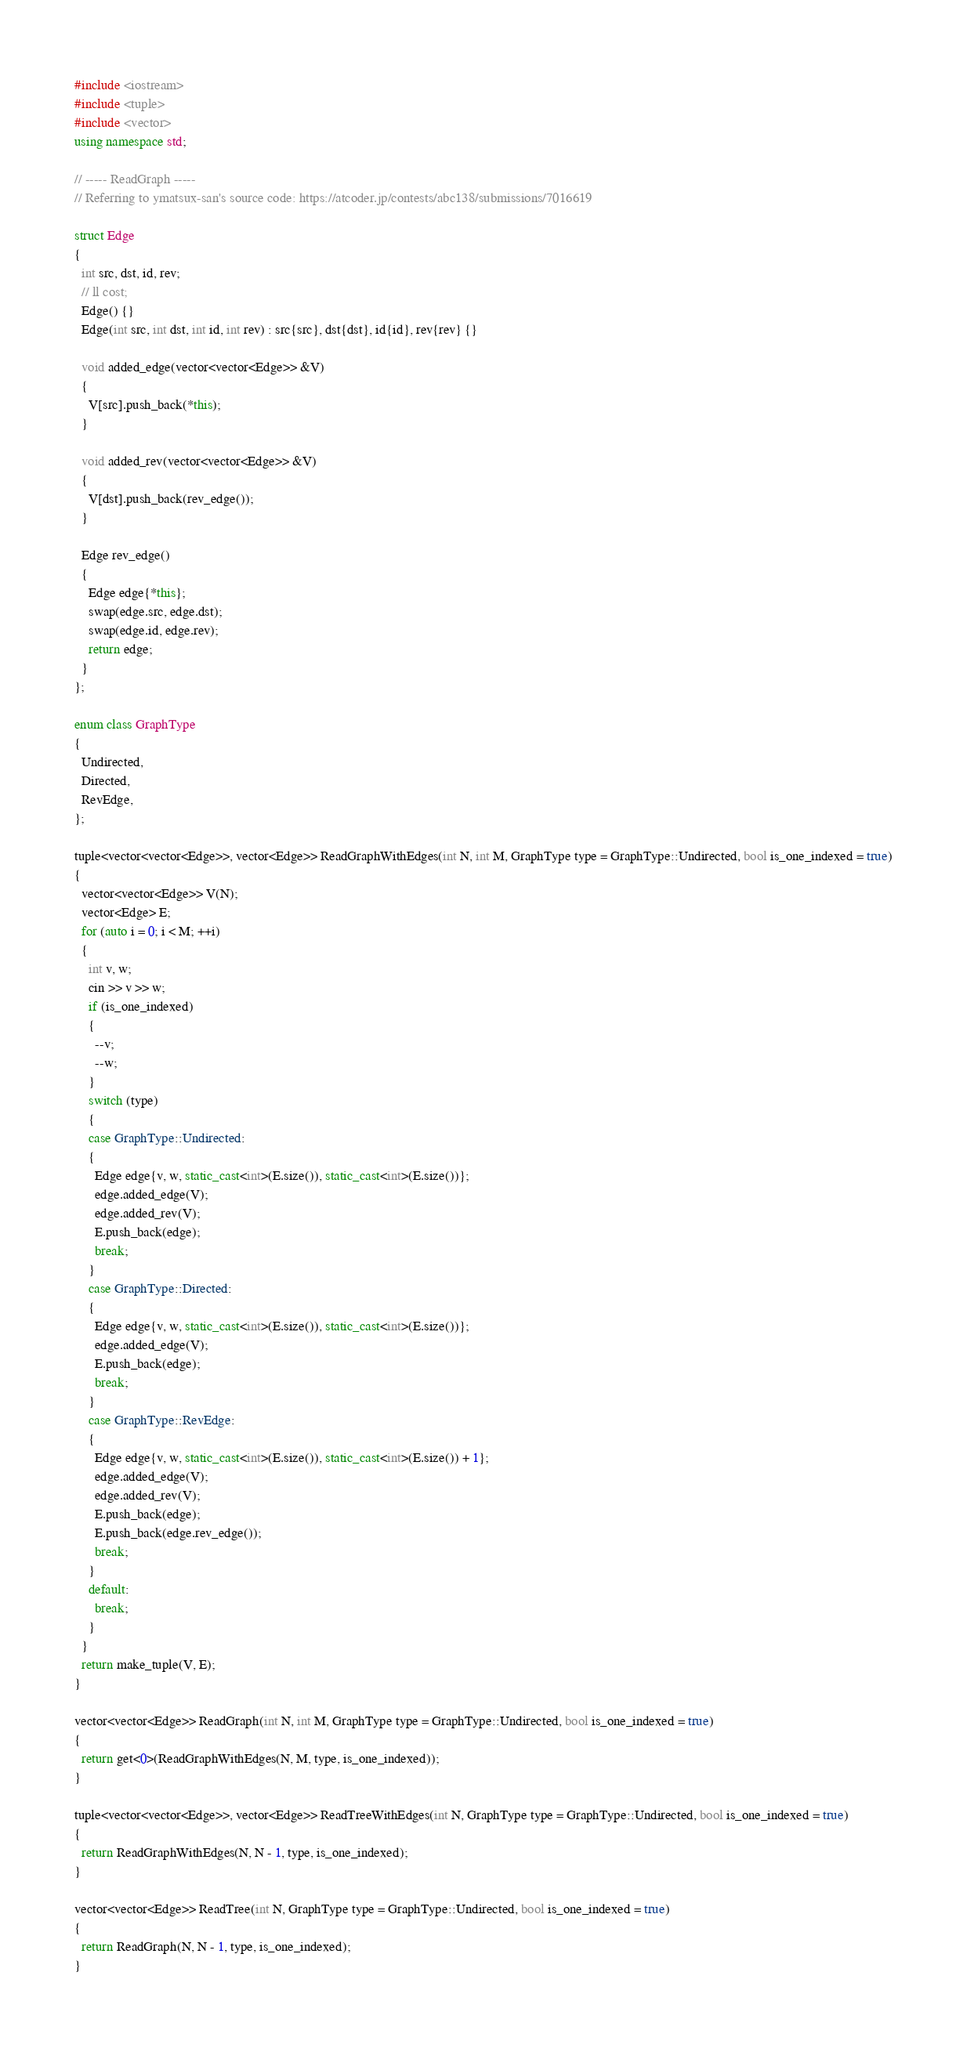<code> <loc_0><loc_0><loc_500><loc_500><_C++_>#include <iostream>
#include <tuple>
#include <vector>
using namespace std;

// ----- ReadGraph -----
// Referring to ymatsux-san's source code: https://atcoder.jp/contests/abc138/submissions/7016619

struct Edge
{
  int src, dst, id, rev;
  // ll cost;
  Edge() {}
  Edge(int src, int dst, int id, int rev) : src{src}, dst{dst}, id{id}, rev{rev} {}

  void added_edge(vector<vector<Edge>> &V)
  {
    V[src].push_back(*this);
  }

  void added_rev(vector<vector<Edge>> &V)
  {
    V[dst].push_back(rev_edge());
  }

  Edge rev_edge()
  {
    Edge edge{*this};
    swap(edge.src, edge.dst);
    swap(edge.id, edge.rev);
    return edge;
  }
};

enum class GraphType
{
  Undirected,
  Directed,
  RevEdge,
};

tuple<vector<vector<Edge>>, vector<Edge>> ReadGraphWithEdges(int N, int M, GraphType type = GraphType::Undirected, bool is_one_indexed = true)
{
  vector<vector<Edge>> V(N);
  vector<Edge> E;
  for (auto i = 0; i < M; ++i)
  {
    int v, w;
    cin >> v >> w;
    if (is_one_indexed)
    {
      --v;
      --w;
    }
    switch (type)
    {
    case GraphType::Undirected:
    {
      Edge edge{v, w, static_cast<int>(E.size()), static_cast<int>(E.size())};
      edge.added_edge(V);
      edge.added_rev(V);
      E.push_back(edge);
      break;
    }
    case GraphType::Directed:
    {
      Edge edge{v, w, static_cast<int>(E.size()), static_cast<int>(E.size())};
      edge.added_edge(V);
      E.push_back(edge);
      break;
    }
    case GraphType::RevEdge:
    {
      Edge edge{v, w, static_cast<int>(E.size()), static_cast<int>(E.size()) + 1};
      edge.added_edge(V);
      edge.added_rev(V);
      E.push_back(edge);
      E.push_back(edge.rev_edge());
      break;
    }
    default:
      break;
    }
  }
  return make_tuple(V, E);
}

vector<vector<Edge>> ReadGraph(int N, int M, GraphType type = GraphType::Undirected, bool is_one_indexed = true)
{
  return get<0>(ReadGraphWithEdges(N, M, type, is_one_indexed));
}

tuple<vector<vector<Edge>>, vector<Edge>> ReadTreeWithEdges(int N, GraphType type = GraphType::Undirected, bool is_one_indexed = true)
{
  return ReadGraphWithEdges(N, N - 1, type, is_one_indexed);
}

vector<vector<Edge>> ReadTree(int N, GraphType type = GraphType::Undirected, bool is_one_indexed = true)
{
  return ReadGraph(N, N - 1, type, is_one_indexed);
}
</code> 